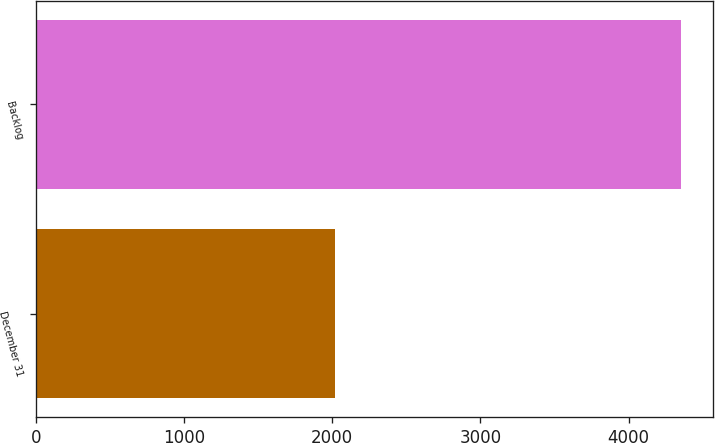Convert chart. <chart><loc_0><loc_0><loc_500><loc_500><bar_chart><fcel>December 31<fcel>Backlog<nl><fcel>2015<fcel>4352<nl></chart> 